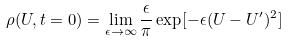Convert formula to latex. <formula><loc_0><loc_0><loc_500><loc_500>\rho ( U , t = 0 ) = \lim _ { \epsilon \rightarrow \infty } \frac { \epsilon } { \pi } \exp [ - \epsilon ( U - U ^ { \prime } ) ^ { 2 } ]</formula> 